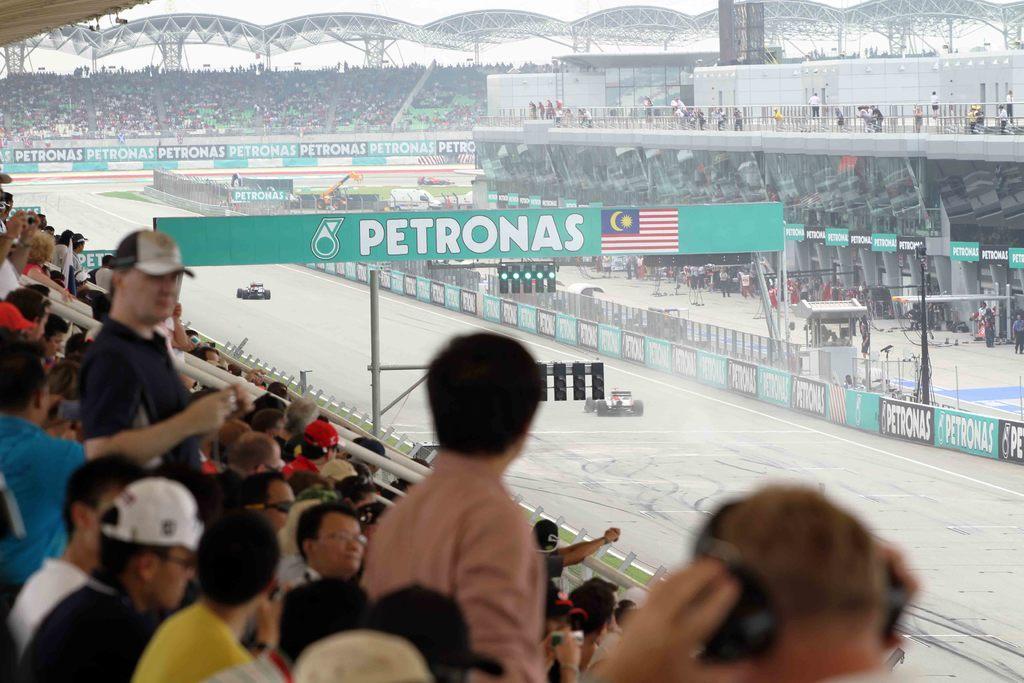In one or two sentences, can you explain what this image depicts? In this picture I can see go-kart cars on the go-kart track, there are group of people, iron rods, boards, lights, and in the background there is sky. 